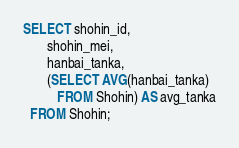Convert code to text. <code><loc_0><loc_0><loc_500><loc_500><_SQL_>SELECT shohin_id, 
       shohin_mei, 
       hanbai_tanka,
       (SELECT AVG(hanbai_tanka)
          FROM Shohin) AS avg_tanka
  FROM Shohin;</code> 